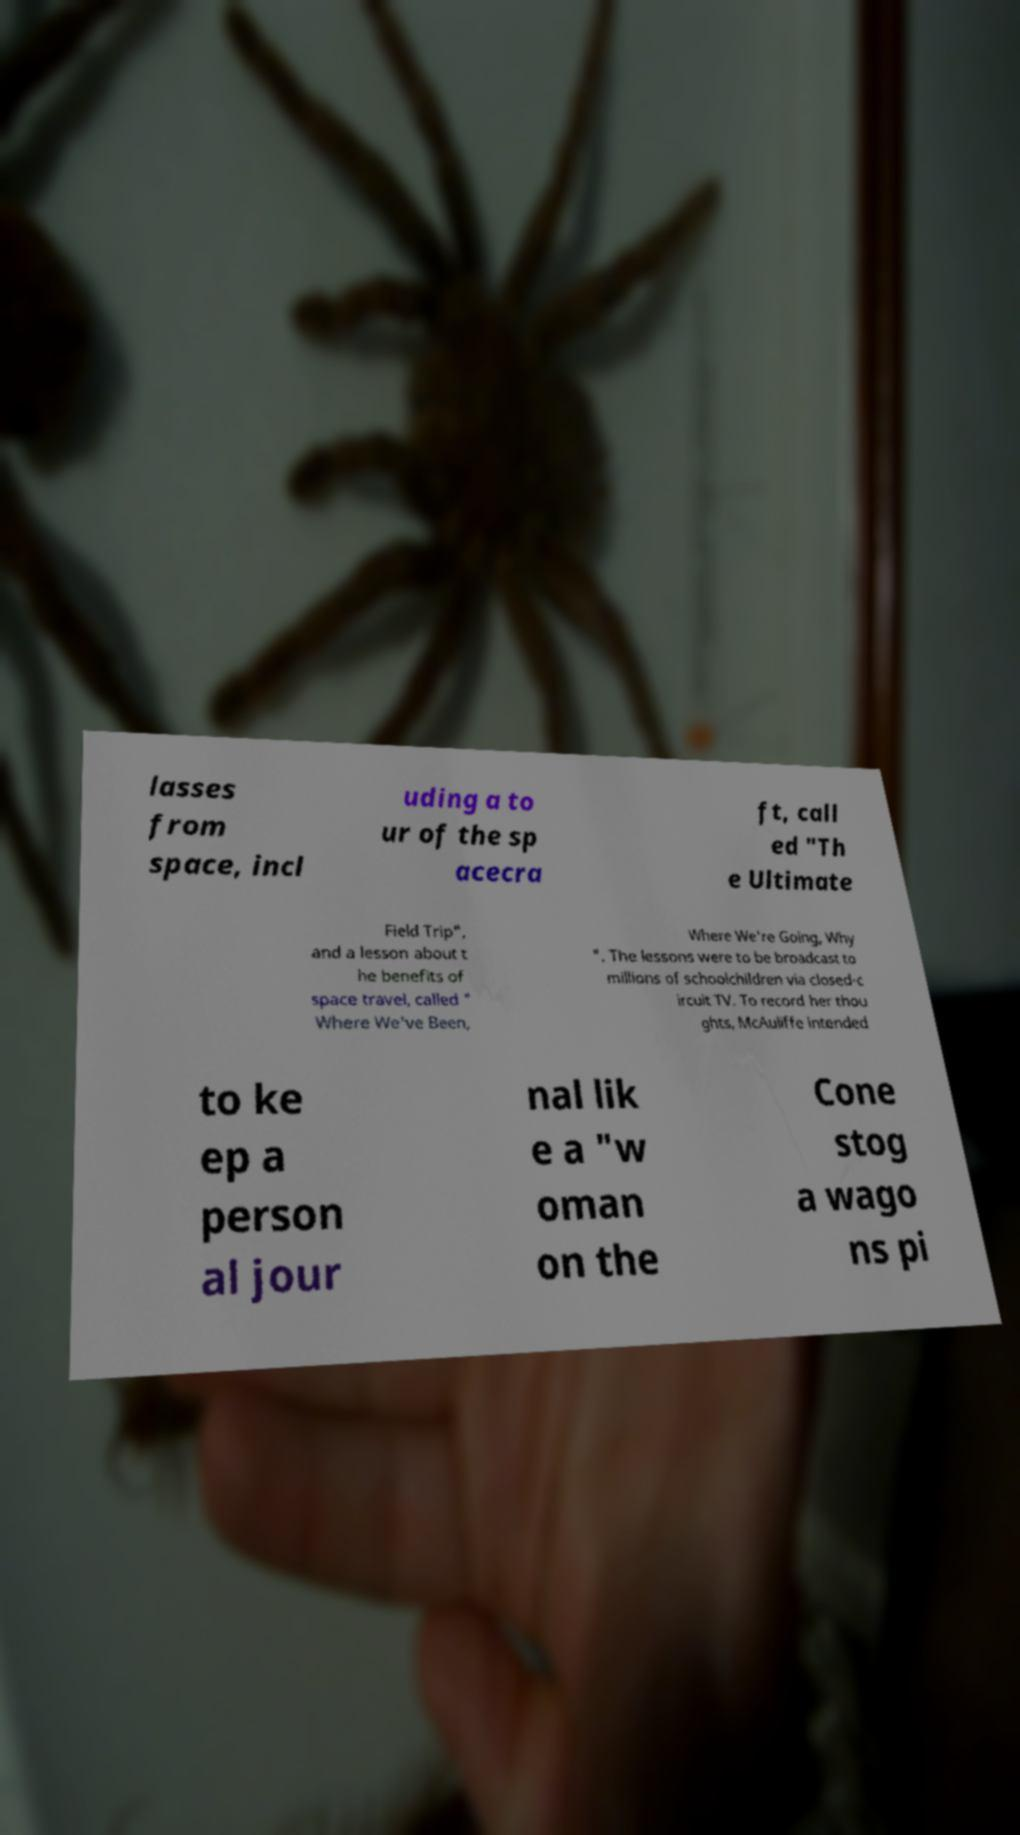Could you assist in decoding the text presented in this image and type it out clearly? lasses from space, incl uding a to ur of the sp acecra ft, call ed "Th e Ultimate Field Trip", and a lesson about t he benefits of space travel, called " Where We've Been, Where We're Going, Why ". The lessons were to be broadcast to millions of schoolchildren via closed-c ircuit TV. To record her thou ghts, McAuliffe intended to ke ep a person al jour nal lik e a "w oman on the Cone stog a wago ns pi 